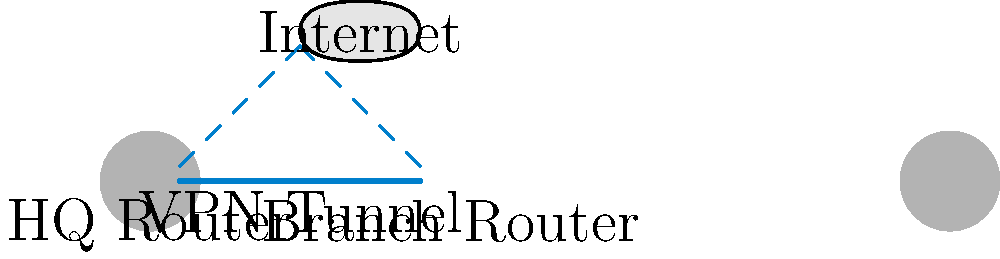In the diagram, a VPN tunnel is established between the HQ Router and the Branch Router through the Internet. What is the primary purpose of using this VPN configuration for secure remote access? To understand the purpose of this VPN configuration for secure remote access, let's break it down step-by-step:

1. Network Layout: The diagram shows two routers (HQ and Branch) connected through the Internet.

2. VPN Tunnel: A solid line represents the VPN tunnel between the two routers, passing through the Internet cloud.

3. Encryption: VPN tunnels encrypt data as it travels through the public Internet, creating a secure "tunnel" for information to pass through.

4. Remote Access: This configuration allows employees at the branch office to securely access resources at the headquarters (and vice versa) as if they were on the same local network.

5. Data Protection: The VPN protects sensitive business data from potential eavesdropping or interception while it travels over the public Internet.

6. Authentication: VPNs also provide authentication mechanisms to ensure that only authorized users and devices can access the network.

7. Scalability: This setup can be easily scaled to include multiple branch offices or remote workers, all connecting securely to the HQ.

The primary purpose of this VPN configuration is to create a secure, encrypted connection between geographically separated office locations, allowing for safe remote access to company resources while protecting data in transit over the public Internet.
Answer: To create a secure, encrypted connection for remote access to company resources. 